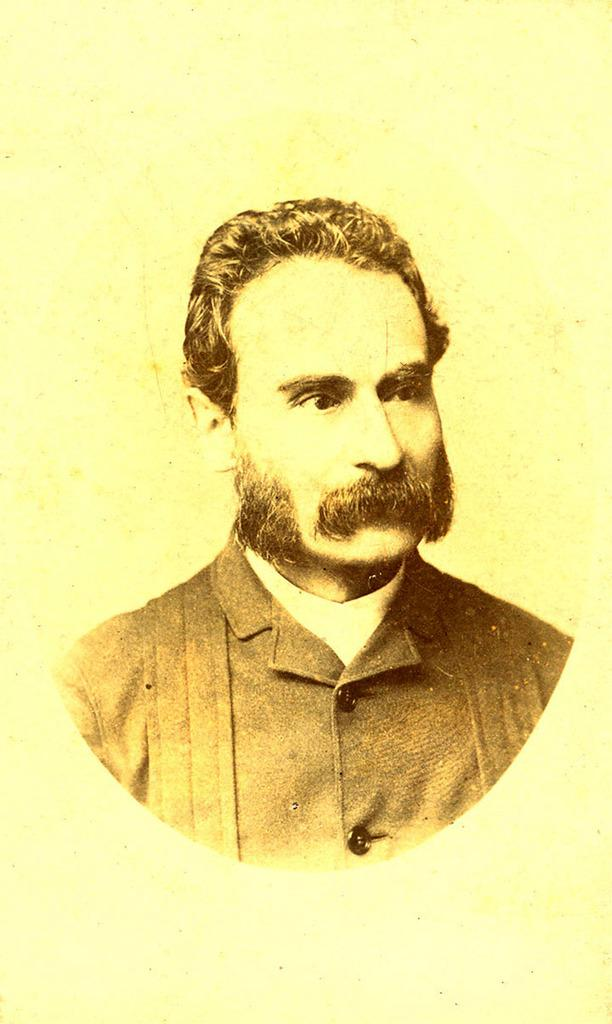What is the main subject of the image? The main subject of the image is a man. Can you describe the man's clothing in the image? The man is wearing black attire in the image. What type of stamp can be seen on the man's forehead in the image? There is no stamp present on the man's forehead in the image. 